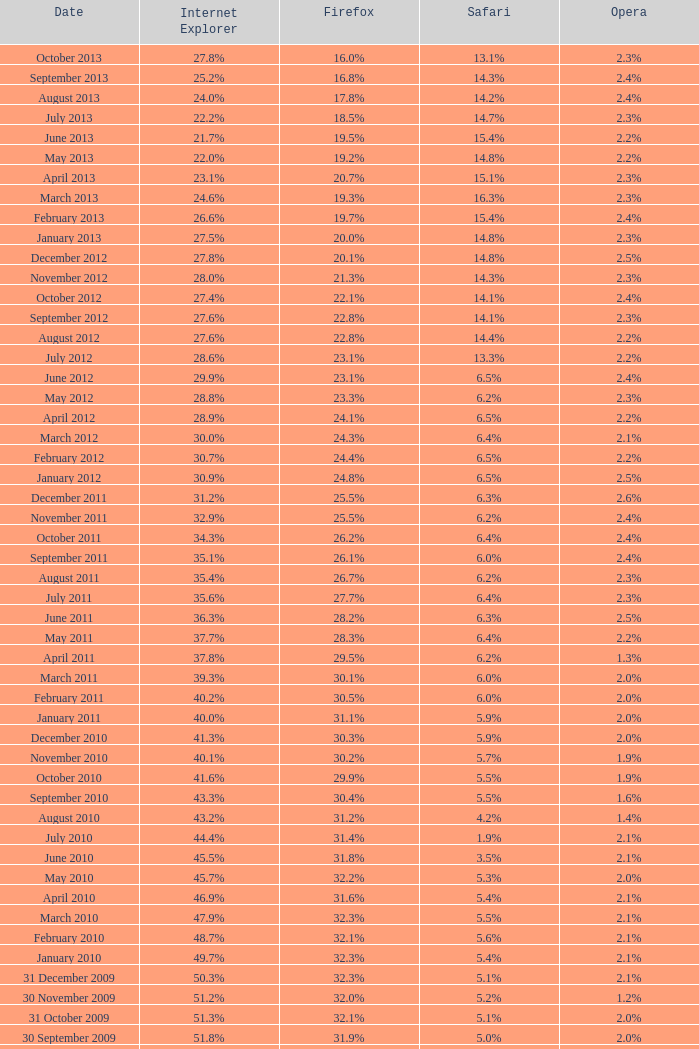What is the safari value with a 28.0% internet explorer? 14.3%. 